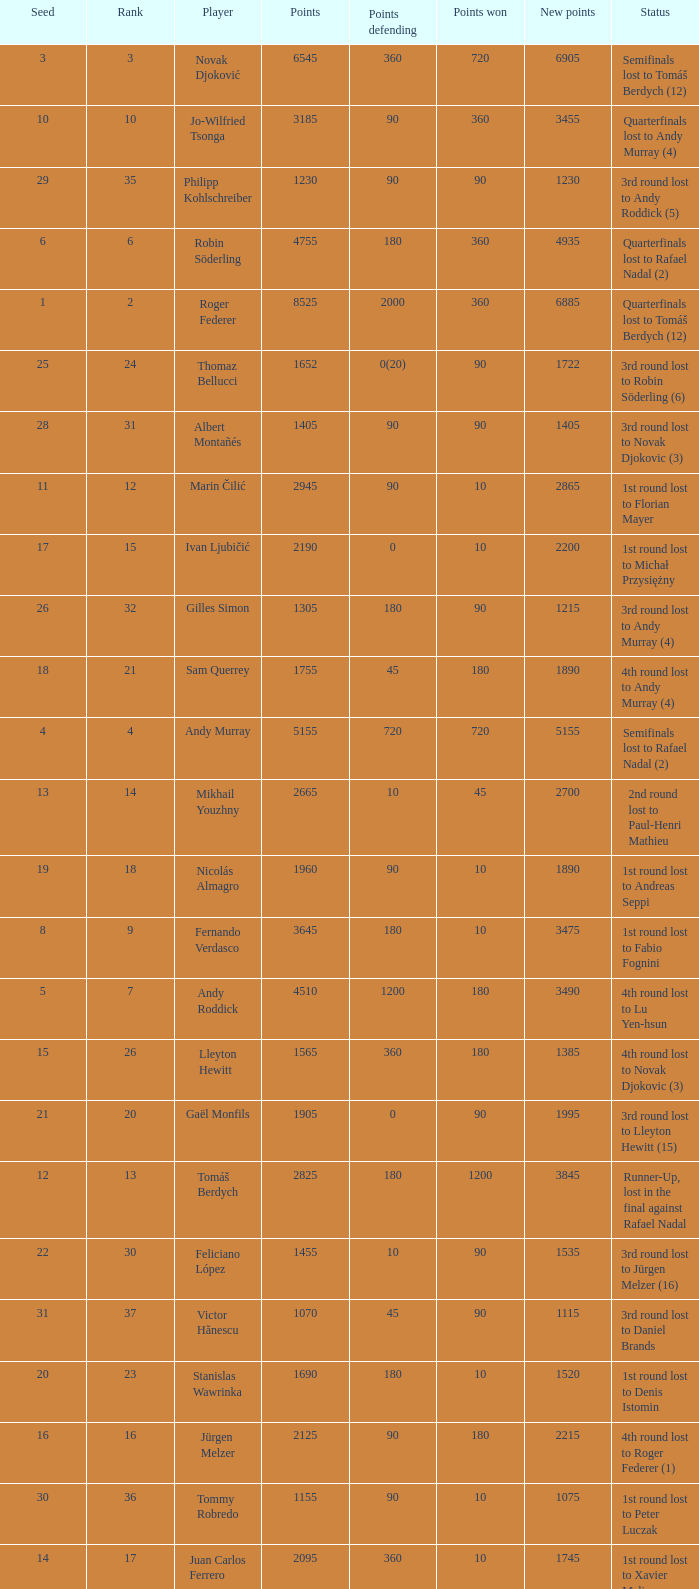Name the points won for 1230 90.0. 